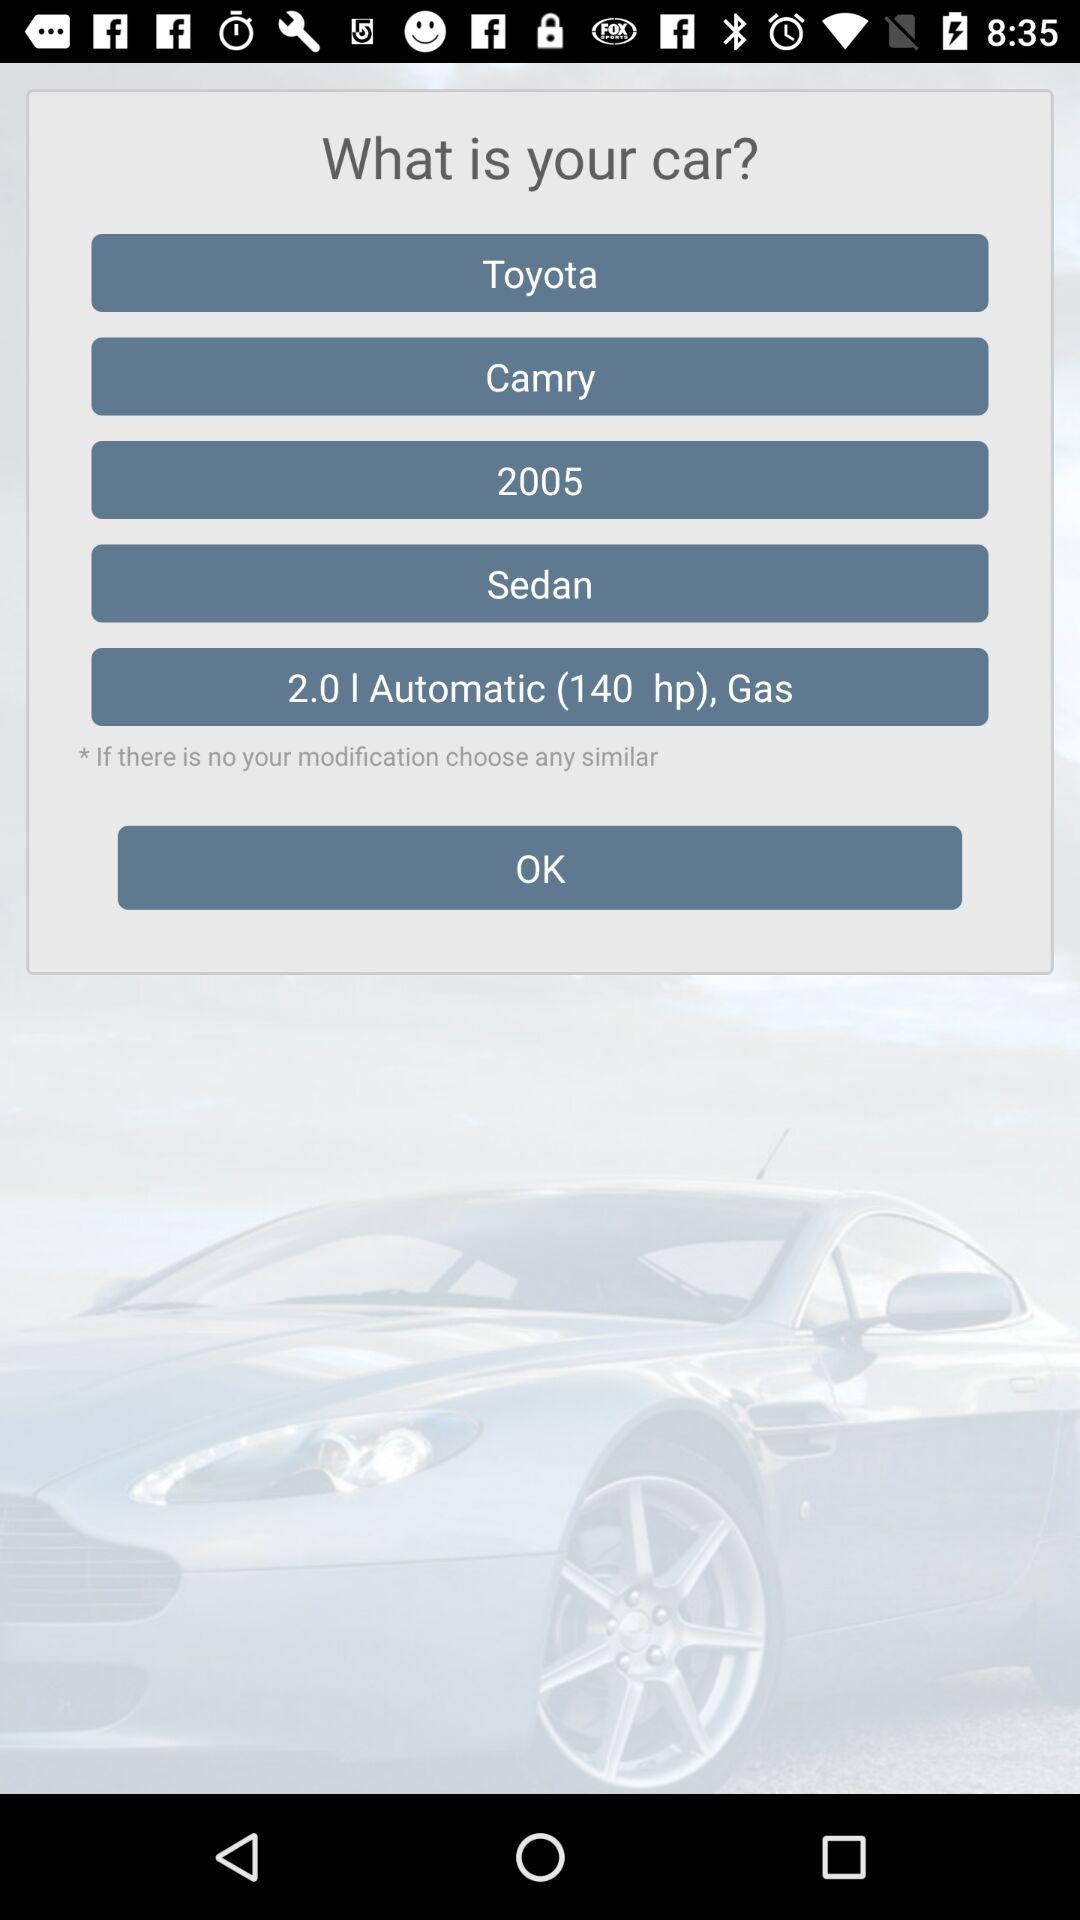What is the car name? The car name is "Toyota Camry". 